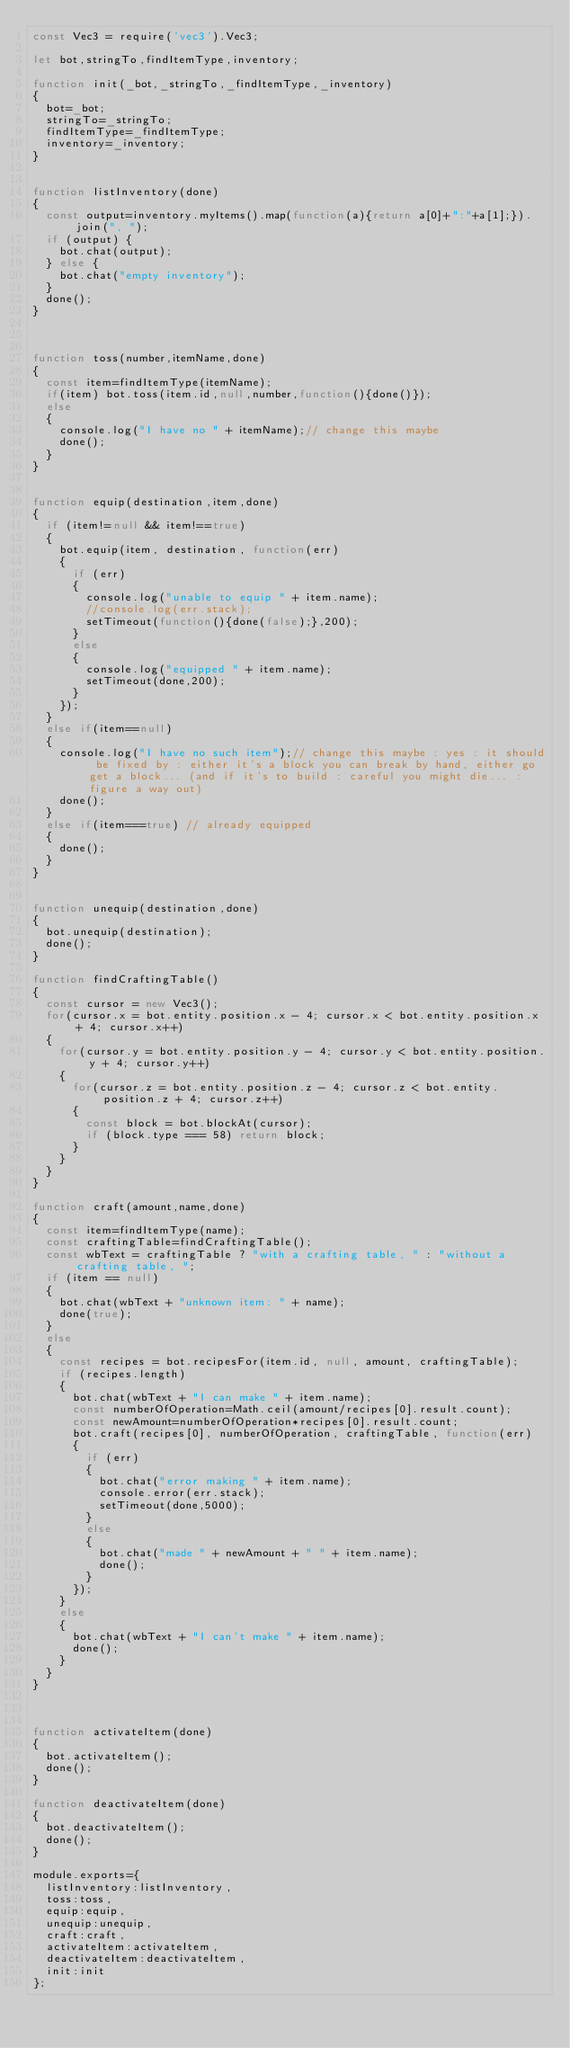<code> <loc_0><loc_0><loc_500><loc_500><_JavaScript_>const Vec3 = require('vec3').Vec3;

let bot,stringTo,findItemType,inventory;

function init(_bot,_stringTo,_findItemType,_inventory)
{
	bot=_bot;
	stringTo=_stringTo;
	findItemType=_findItemType;
	inventory=_inventory;
}


function listInventory(done)
{
	const output=inventory.myItems().map(function(a){return a[0]+":"+a[1];}).join(", ");
	if (output) {
		bot.chat(output);
	} else {
		bot.chat("empty inventory");
	}
	done();
}



function toss(number,itemName,done)
{
	const item=findItemType(itemName);
	if(item) bot.toss(item.id,null,number,function(){done()});
	else
	{
		console.log("I have no " + itemName);// change this maybe
		done();
	}
}


function equip(destination,item,done)
{
	if (item!=null && item!==true)
	{
		bot.equip(item, destination, function(err) 
		{
			if (err)
			{
				console.log("unable to equip " + item.name);
				//console.log(err.stack);
				setTimeout(function(){done(false);},200);
			}
			else
			{
				console.log("equipped " + item.name);
				setTimeout(done,200);
			}
		});
	}
	else if(item==null)
	{
		console.log("I have no such item");// change this maybe : yes : it should be fixed by : either it's a block you can break by hand, either go get a block... (and if it's to build : careful you might die... : figure a way out)
		done();
	}
	else if(item===true) // already equipped
	{
		done();
	}	
}


function unequip(destination,done)
{
	bot.unequip(destination);
	done();
}

function findCraftingTable()
{
	const cursor = new Vec3();
	for(cursor.x = bot.entity.position.x - 4; cursor.x < bot.entity.position.x + 4; cursor.x++)
	{
		for(cursor.y = bot.entity.position.y - 4; cursor.y < bot.entity.position.y + 4; cursor.y++)
		{
			for(cursor.z = bot.entity.position.z - 4; cursor.z < bot.entity.position.z + 4; cursor.z++)
			{
				const block = bot.blockAt(cursor);
				if (block.type === 58) return block;
			}
		}
	}
}

function craft(amount,name,done)
{
	const item=findItemType(name);
	const craftingTable=findCraftingTable();
	const wbText = craftingTable ? "with a crafting table, " : "without a crafting table, ";
	if (item == null)
	{
		bot.chat(wbText + "unknown item: " + name);
		done(true);
	}
	else
	{
		const recipes = bot.recipesFor(item.id, null, amount, craftingTable);
		if (recipes.length)
		{
			bot.chat(wbText + "I can make " + item.name);
			const numberOfOperation=Math.ceil(amount/recipes[0].result.count);
			const newAmount=numberOfOperation*recipes[0].result.count;
			bot.craft(recipes[0], numberOfOperation, craftingTable, function(err)
			{
				if (err)
				{
					bot.chat("error making " + item.name);
					console.error(err.stack);
					setTimeout(done,5000);
				}
				else
				{	
					bot.chat("made " + newAmount + " " + item.name);
					done();
				}
			});
		}
		else
		{
			bot.chat(wbText + "I can't make " + item.name);
			done();
		}
	}
}



function activateItem(done)
{
	bot.activateItem();
	done();
}

function deactivateItem(done)
{
	bot.deactivateItem();
	done();
}

module.exports={
	listInventory:listInventory,
	toss:toss,
	equip:equip,
	unequip:unequip,
	craft:craft,
	activateItem:activateItem,
	deactivateItem:deactivateItem,
	init:init
};</code> 